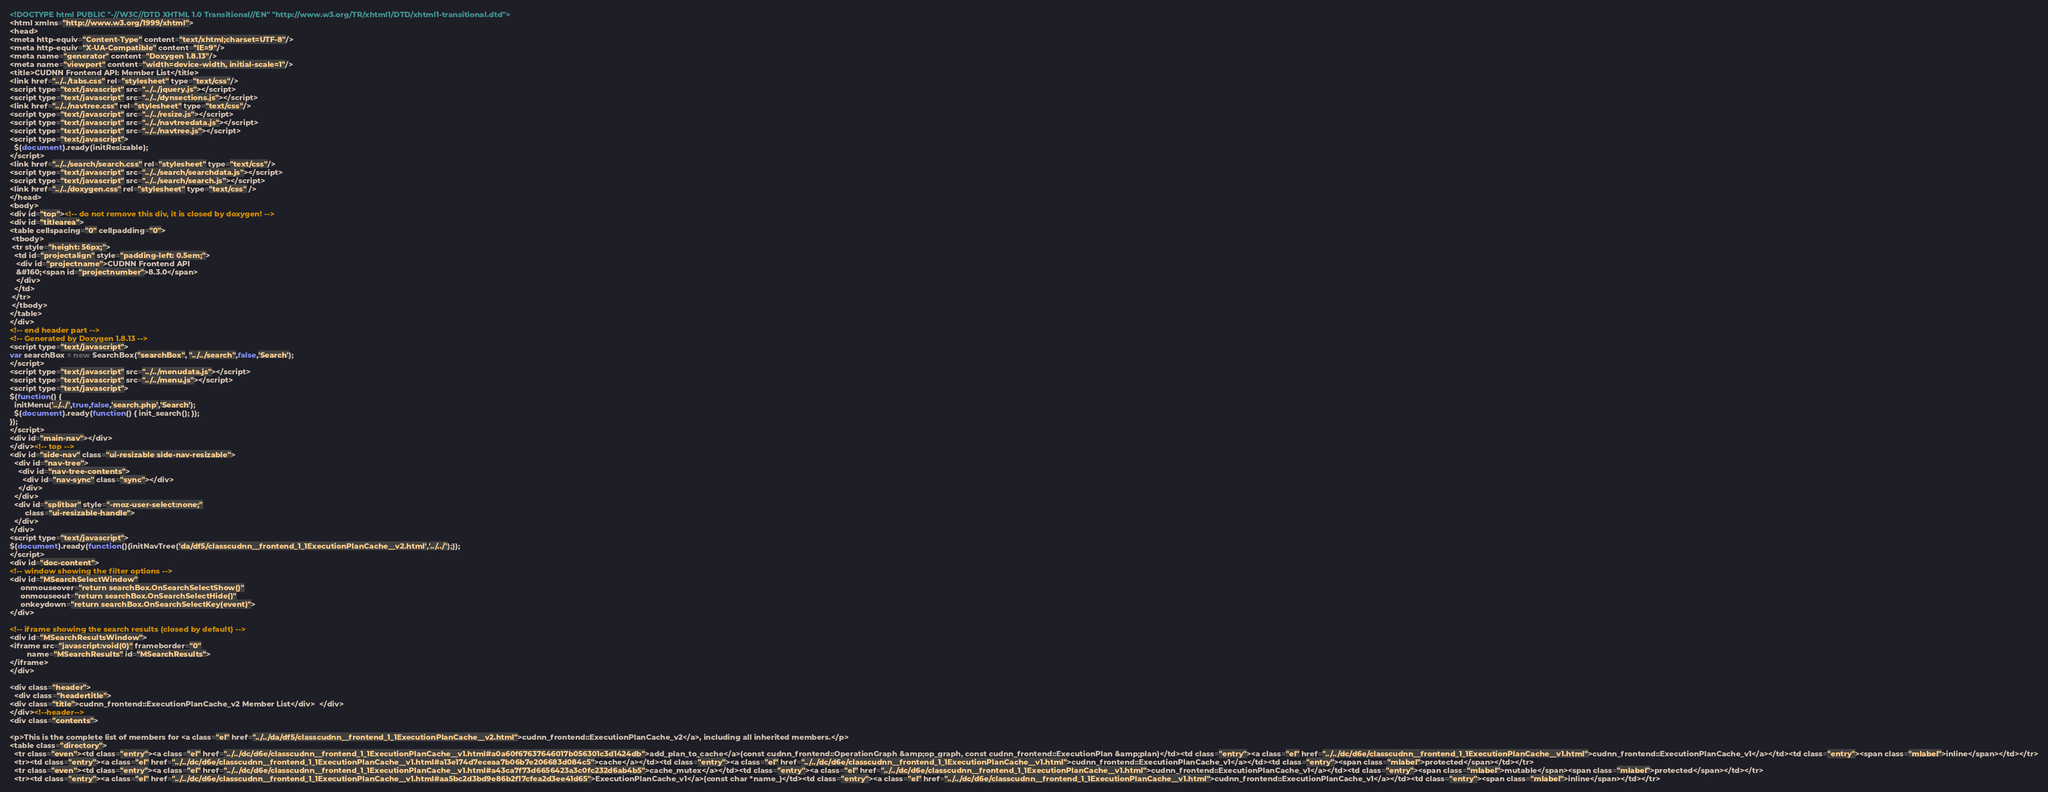<code> <loc_0><loc_0><loc_500><loc_500><_HTML_><!DOCTYPE html PUBLIC "-//W3C//DTD XHTML 1.0 Transitional//EN" "http://www.w3.org/TR/xhtml1/DTD/xhtml1-transitional.dtd">
<html xmlns="http://www.w3.org/1999/xhtml">
<head>
<meta http-equiv="Content-Type" content="text/xhtml;charset=UTF-8"/>
<meta http-equiv="X-UA-Compatible" content="IE=9"/>
<meta name="generator" content="Doxygen 1.8.13"/>
<meta name="viewport" content="width=device-width, initial-scale=1"/>
<title>CUDNN Frontend API: Member List</title>
<link href="../../tabs.css" rel="stylesheet" type="text/css"/>
<script type="text/javascript" src="../../jquery.js"></script>
<script type="text/javascript" src="../../dynsections.js"></script>
<link href="../../navtree.css" rel="stylesheet" type="text/css"/>
<script type="text/javascript" src="../../resize.js"></script>
<script type="text/javascript" src="../../navtreedata.js"></script>
<script type="text/javascript" src="../../navtree.js"></script>
<script type="text/javascript">
  $(document).ready(initResizable);
</script>
<link href="../../search/search.css" rel="stylesheet" type="text/css"/>
<script type="text/javascript" src="../../search/searchdata.js"></script>
<script type="text/javascript" src="../../search/search.js"></script>
<link href="../../doxygen.css" rel="stylesheet" type="text/css" />
</head>
<body>
<div id="top"><!-- do not remove this div, it is closed by doxygen! -->
<div id="titlearea">
<table cellspacing="0" cellpadding="0">
 <tbody>
 <tr style="height: 56px;">
  <td id="projectalign" style="padding-left: 0.5em;">
   <div id="projectname">CUDNN Frontend API
   &#160;<span id="projectnumber">8.3.0</span>
   </div>
  </td>
 </tr>
 </tbody>
</table>
</div>
<!-- end header part -->
<!-- Generated by Doxygen 1.8.13 -->
<script type="text/javascript">
var searchBox = new SearchBox("searchBox", "../../search",false,'Search');
</script>
<script type="text/javascript" src="../../menudata.js"></script>
<script type="text/javascript" src="../../menu.js"></script>
<script type="text/javascript">
$(function() {
  initMenu('../../',true,false,'search.php','Search');
  $(document).ready(function() { init_search(); });
});
</script>
<div id="main-nav"></div>
</div><!-- top -->
<div id="side-nav" class="ui-resizable side-nav-resizable">
  <div id="nav-tree">
    <div id="nav-tree-contents">
      <div id="nav-sync" class="sync"></div>
    </div>
  </div>
  <div id="splitbar" style="-moz-user-select:none;" 
       class="ui-resizable-handle">
  </div>
</div>
<script type="text/javascript">
$(document).ready(function(){initNavTree('da/df5/classcudnn__frontend_1_1ExecutionPlanCache__v2.html','../../');});
</script>
<div id="doc-content">
<!-- window showing the filter options -->
<div id="MSearchSelectWindow"
     onmouseover="return searchBox.OnSearchSelectShow()"
     onmouseout="return searchBox.OnSearchSelectHide()"
     onkeydown="return searchBox.OnSearchSelectKey(event)">
</div>

<!-- iframe showing the search results (closed by default) -->
<div id="MSearchResultsWindow">
<iframe src="javascript:void(0)" frameborder="0" 
        name="MSearchResults" id="MSearchResults">
</iframe>
</div>

<div class="header">
  <div class="headertitle">
<div class="title">cudnn_frontend::ExecutionPlanCache_v2 Member List</div>  </div>
</div><!--header-->
<div class="contents">

<p>This is the complete list of members for <a class="el" href="../../da/df5/classcudnn__frontend_1_1ExecutionPlanCache__v2.html">cudnn_frontend::ExecutionPlanCache_v2</a>, including all inherited members.</p>
<table class="directory">
  <tr class="even"><td class="entry"><a class="el" href="../../dc/d6e/classcudnn__frontend_1_1ExecutionPlanCache__v1.html#a0a60f67637646017b056301c3d1424db">add_plan_to_cache</a>(const cudnn_frontend::OperationGraph &amp;op_graph, const cudnn_frontend::ExecutionPlan &amp;plan)</td><td class="entry"><a class="el" href="../../dc/d6e/classcudnn__frontend_1_1ExecutionPlanCache__v1.html">cudnn_frontend::ExecutionPlanCache_v1</a></td><td class="entry"><span class="mlabel">inline</span></td></tr>
  <tr><td class="entry"><a class="el" href="../../dc/d6e/classcudnn__frontend_1_1ExecutionPlanCache__v1.html#a13e174d7eceaa7b06b7e206683d084c5">cache</a></td><td class="entry"><a class="el" href="../../dc/d6e/classcudnn__frontend_1_1ExecutionPlanCache__v1.html">cudnn_frontend::ExecutionPlanCache_v1</a></td><td class="entry"><span class="mlabel">protected</span></td></tr>
  <tr class="even"><td class="entry"><a class="el" href="../../dc/d6e/classcudnn__frontend_1_1ExecutionPlanCache__v1.html#a43ca7f73d6656423a3c0fc232d6ab4b5">cache_mutex</a></td><td class="entry"><a class="el" href="../../dc/d6e/classcudnn__frontend_1_1ExecutionPlanCache__v1.html">cudnn_frontend::ExecutionPlanCache_v1</a></td><td class="entry"><span class="mlabel">mutable</span><span class="mlabel">protected</span></td></tr>
  <tr><td class="entry"><a class="el" href="../../dc/d6e/classcudnn__frontend_1_1ExecutionPlanCache__v1.html#aa5bc2d3bd9e86b2f17cfea2d3ee41d65">ExecutionPlanCache_v1</a>(const char *name_)</td><td class="entry"><a class="el" href="../../dc/d6e/classcudnn__frontend_1_1ExecutionPlanCache__v1.html">cudnn_frontend::ExecutionPlanCache_v1</a></td><td class="entry"><span class="mlabel">inline</span></td></tr></code> 